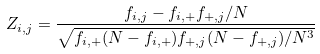Convert formula to latex. <formula><loc_0><loc_0><loc_500><loc_500>Z _ { i , j } = \frac { f _ { i , j } - f _ { i , + } f _ { + , j } / N } { \sqrt { f _ { i , + } ( N - f _ { i , + } ) f _ { + , j } ( N - f _ { + , j } ) / N ^ { 3 } } }</formula> 